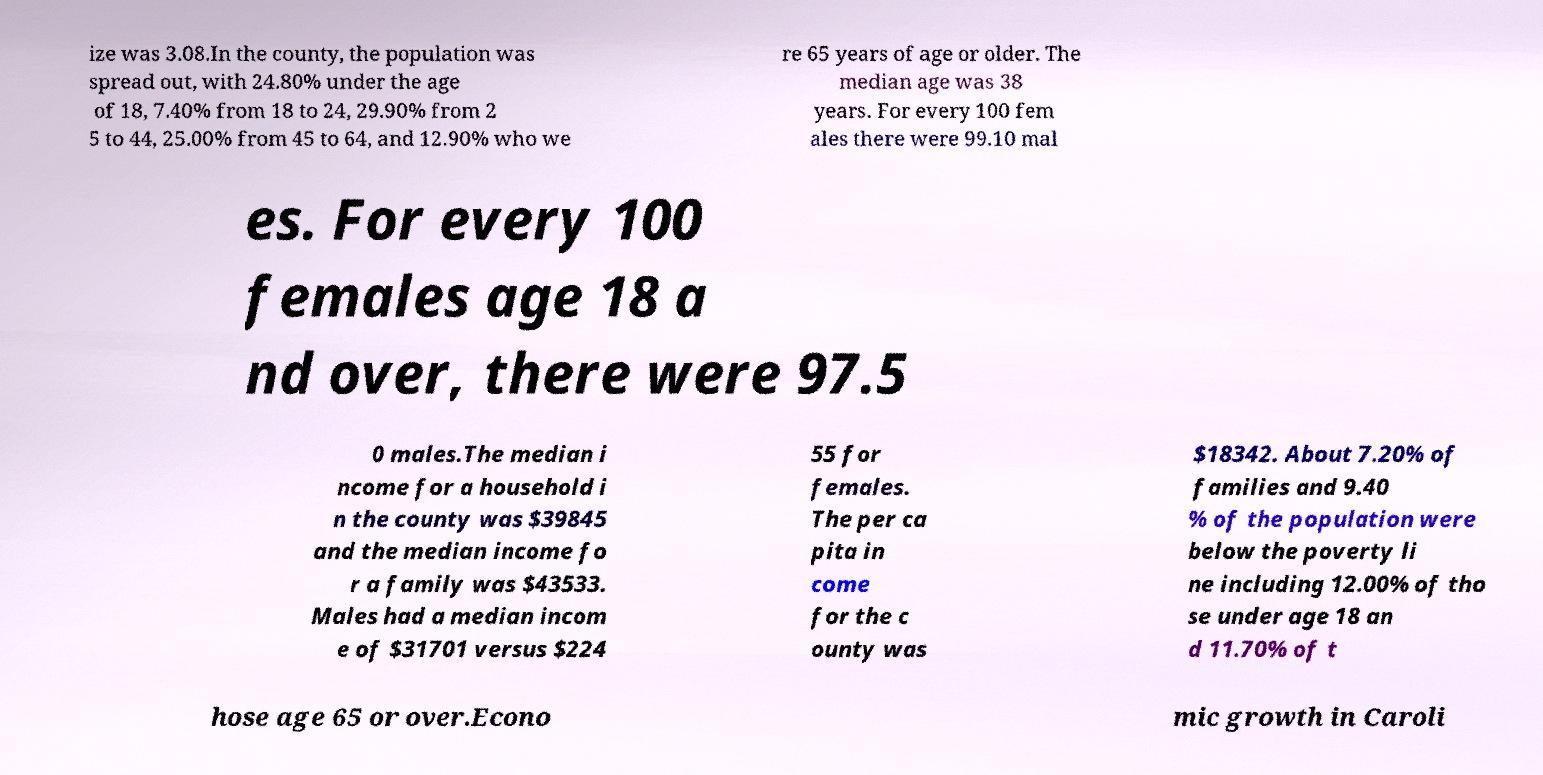I need the written content from this picture converted into text. Can you do that? ize was 3.08.In the county, the population was spread out, with 24.80% under the age of 18, 7.40% from 18 to 24, 29.90% from 2 5 to 44, 25.00% from 45 to 64, and 12.90% who we re 65 years of age or older. The median age was 38 years. For every 100 fem ales there were 99.10 mal es. For every 100 females age 18 a nd over, there were 97.5 0 males.The median i ncome for a household i n the county was $39845 and the median income fo r a family was $43533. Males had a median incom e of $31701 versus $224 55 for females. The per ca pita in come for the c ounty was $18342. About 7.20% of families and 9.40 % of the population were below the poverty li ne including 12.00% of tho se under age 18 an d 11.70% of t hose age 65 or over.Econo mic growth in Caroli 